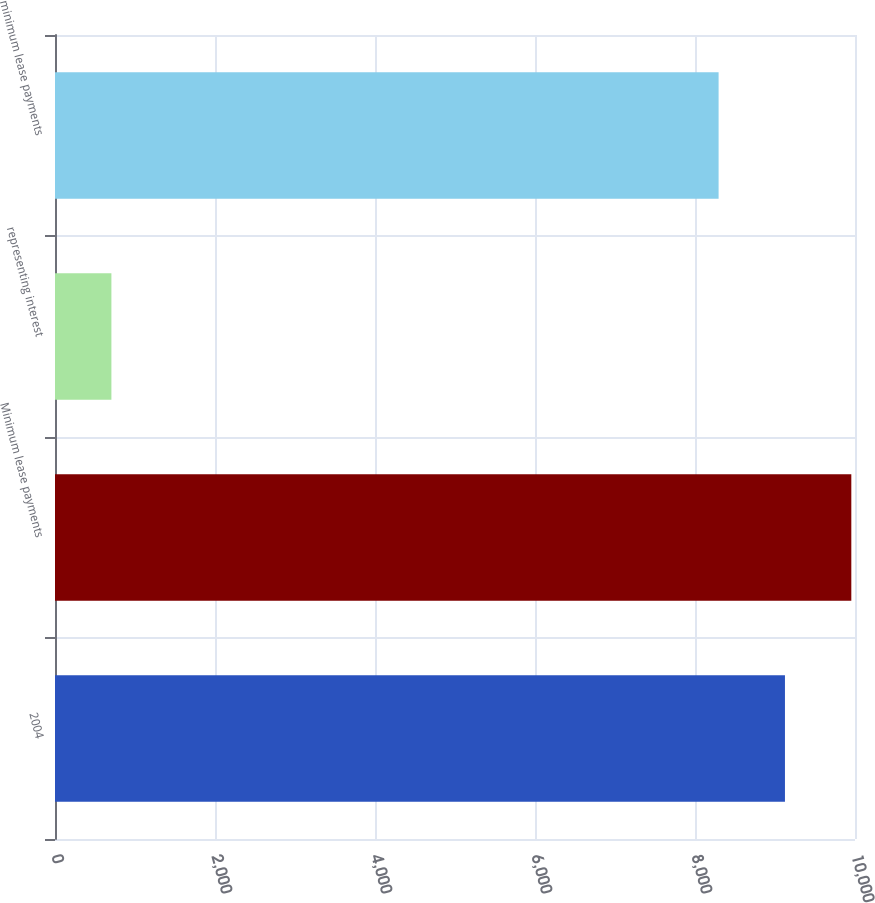<chart> <loc_0><loc_0><loc_500><loc_500><bar_chart><fcel>2004<fcel>Minimum lease payments<fcel>representing interest<fcel>minimum lease payments<nl><fcel>9124.5<fcel>9954<fcel>705<fcel>8295<nl></chart> 